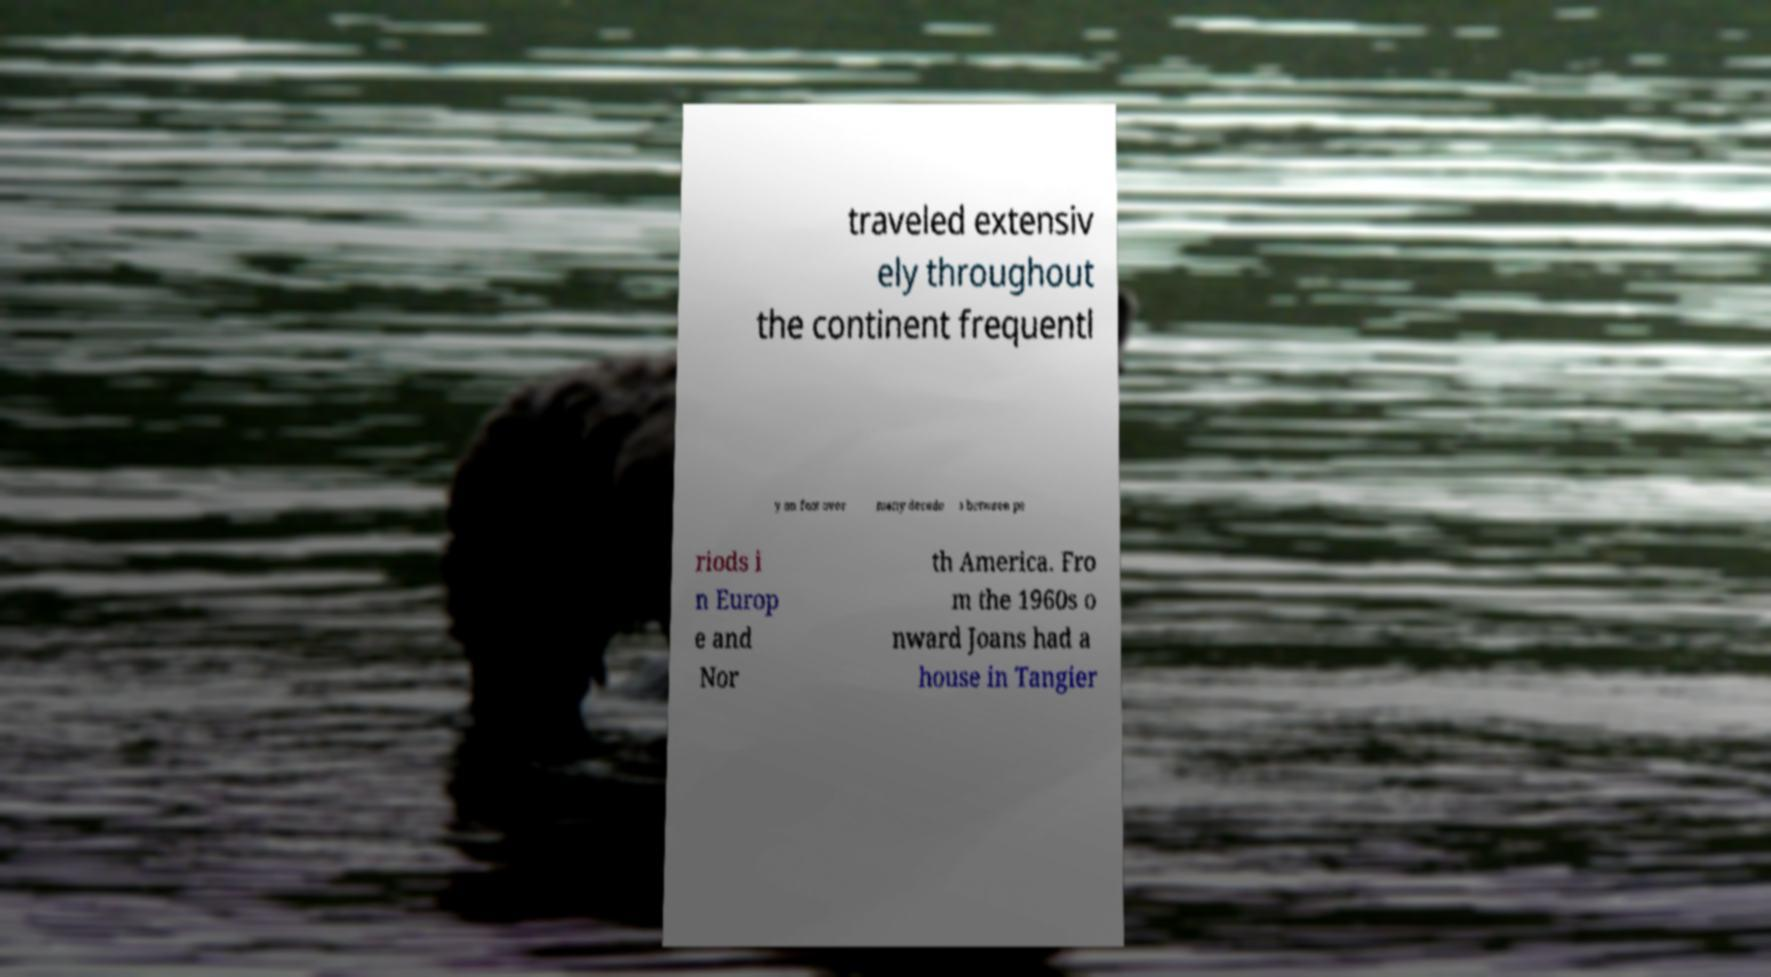What messages or text are displayed in this image? I need them in a readable, typed format. traveled extensiv ely throughout the continent frequentl y on foot over many decade s between pe riods i n Europ e and Nor th America. Fro m the 1960s o nward Joans had a house in Tangier 